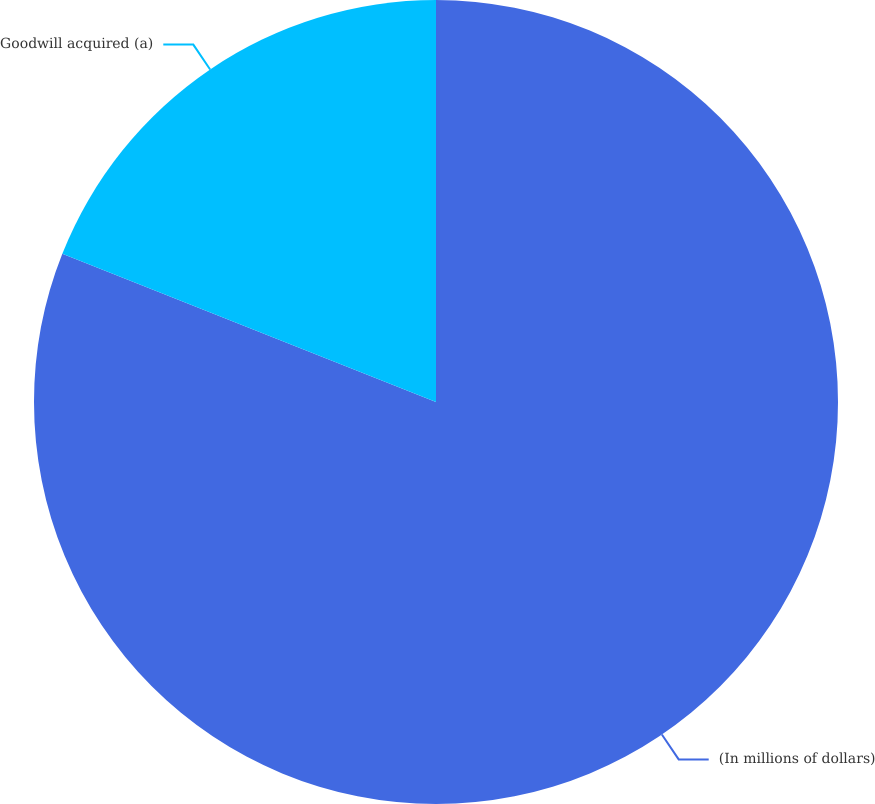Convert chart to OTSL. <chart><loc_0><loc_0><loc_500><loc_500><pie_chart><fcel>(In millions of dollars)<fcel>Goodwill acquired (a)<nl><fcel>81.01%<fcel>18.99%<nl></chart> 